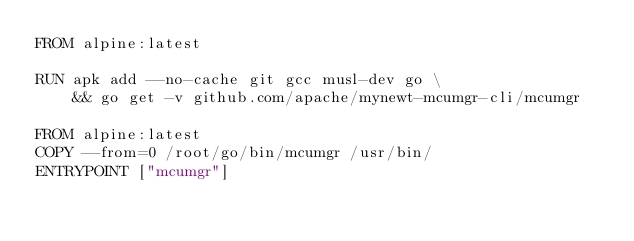<code> <loc_0><loc_0><loc_500><loc_500><_Dockerfile_>FROM alpine:latest

RUN apk add --no-cache git gcc musl-dev go \
	&& go get -v github.com/apache/mynewt-mcumgr-cli/mcumgr

FROM alpine:latest
COPY --from=0 /root/go/bin/mcumgr /usr/bin/
ENTRYPOINT ["mcumgr"]
</code> 